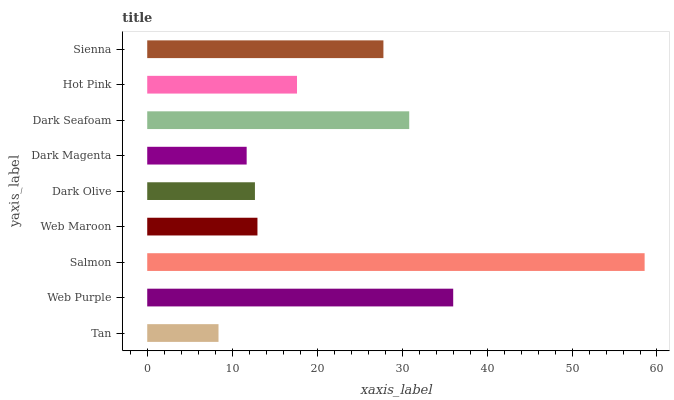Is Tan the minimum?
Answer yes or no. Yes. Is Salmon the maximum?
Answer yes or no. Yes. Is Web Purple the minimum?
Answer yes or no. No. Is Web Purple the maximum?
Answer yes or no. No. Is Web Purple greater than Tan?
Answer yes or no. Yes. Is Tan less than Web Purple?
Answer yes or no. Yes. Is Tan greater than Web Purple?
Answer yes or no. No. Is Web Purple less than Tan?
Answer yes or no. No. Is Hot Pink the high median?
Answer yes or no. Yes. Is Hot Pink the low median?
Answer yes or no. Yes. Is Sienna the high median?
Answer yes or no. No. Is Web Purple the low median?
Answer yes or no. No. 